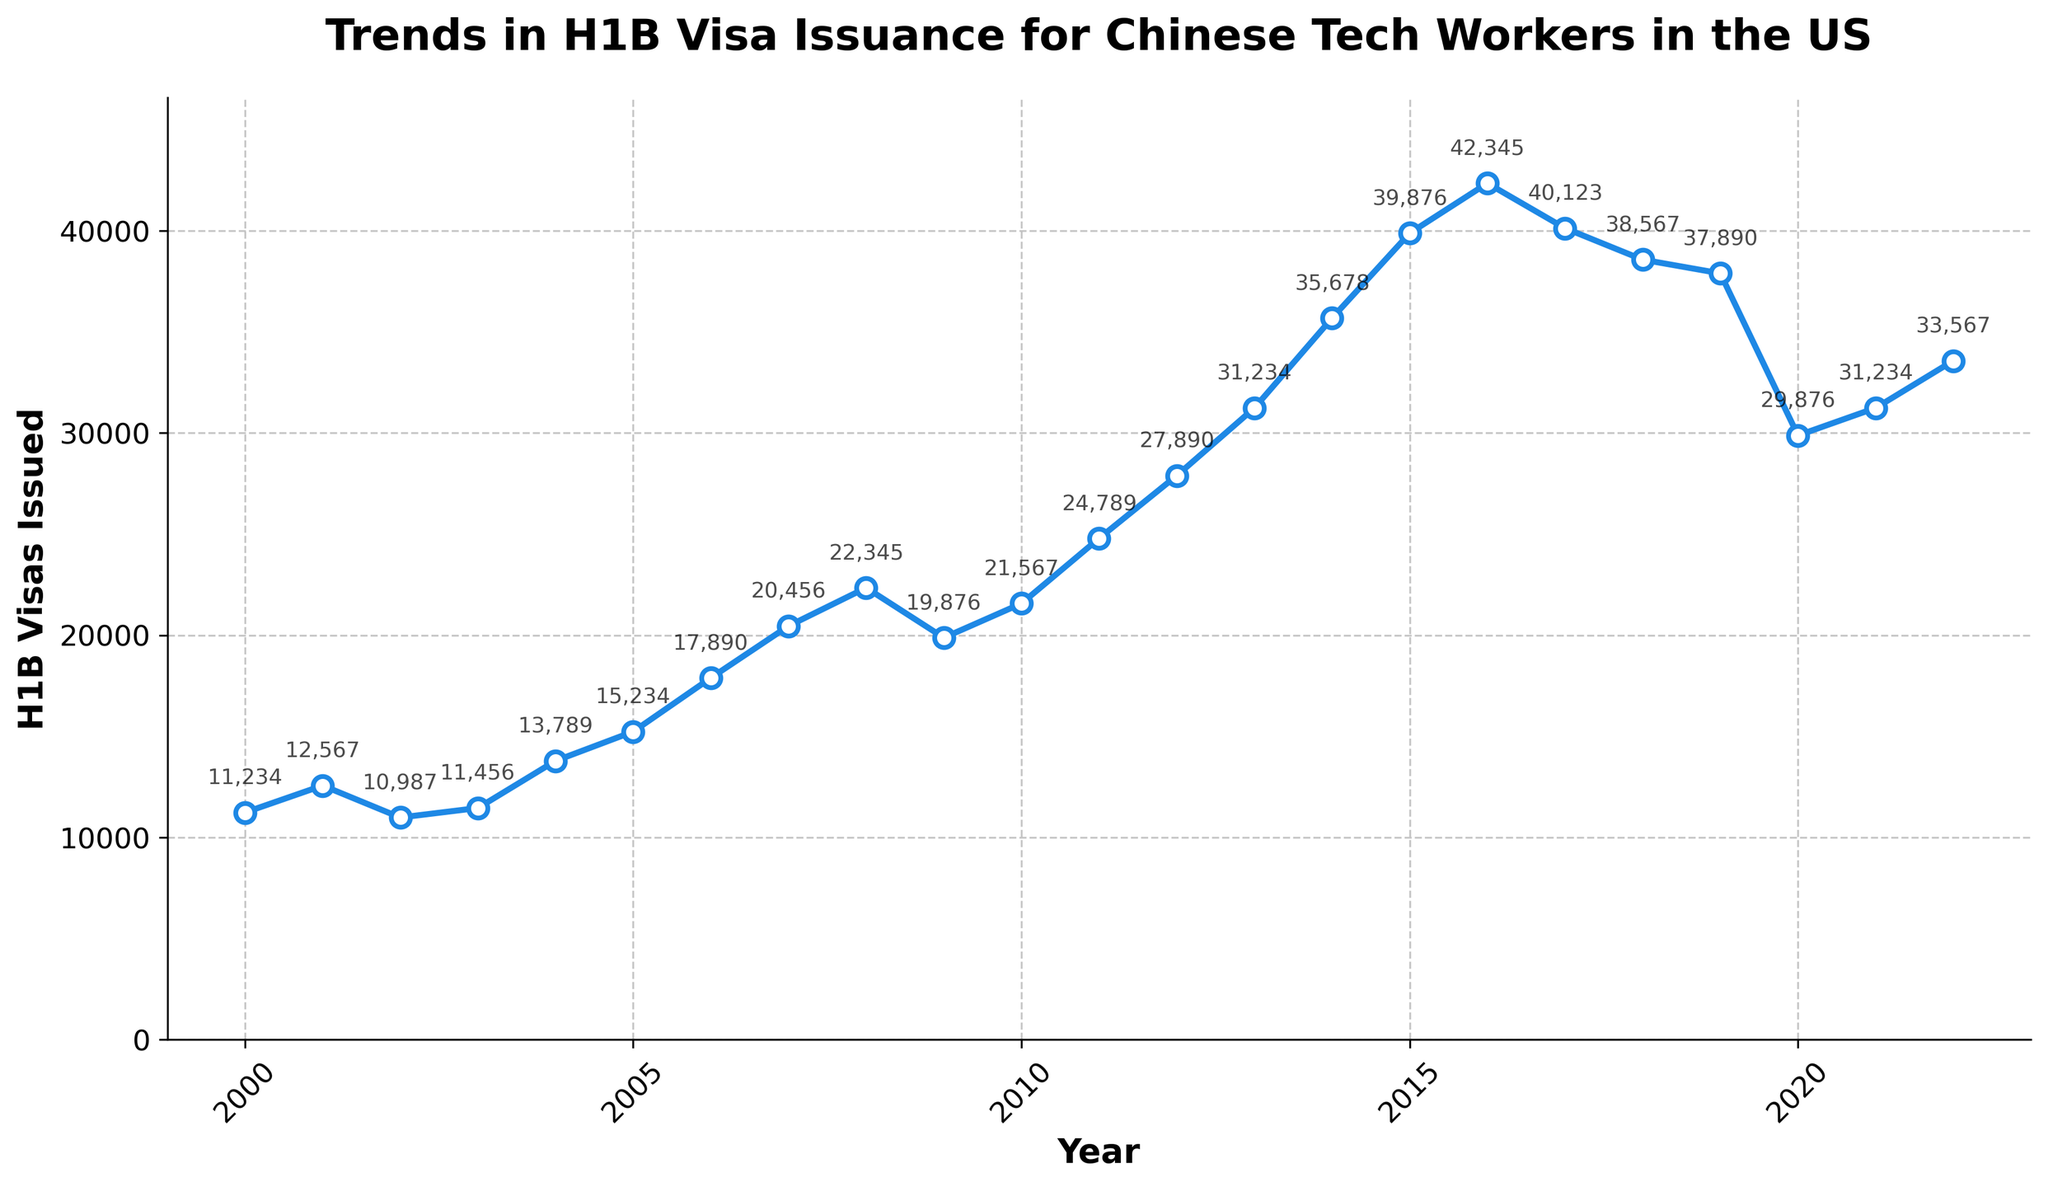What is the peak year for H1B visa issuance to Chinese tech workers? The peak year can be identified by finding the year with the highest number of H1B visas issued. The chart shows that the highest value is in 2016 with 42,345 visas issued.
Answer: 2016 Between 2000 and 2022, which year experienced the largest drop in H1B visa issuance compared to the previous year? To determine the largest drop, we need to find the year-to-year differences and identify the largest negative difference. The biggest drop is between 2019 and 2020 (37,890 to 29,876), a decrease of 8,014.
Answer: 2020 What is the overall trend in H1B visa issuance from 2000 to 2022? Observing the data points, the overall trend shows an increase in visa issuance from 2000 to 2016, followed by fluctuations and a notable decrease in 2020, before stabilizing again.
Answer: Increasing until 2016, then fluctuating with a decrease in 2020, and stabilizing From 2011 to 2015, how much did the number of H1B visas issued increase? To find the increase, subtract the number of visas issued in 2011 from those issued in 2015: 39,876 (2015) - 24,789 (2011) = 15,087.
Answer: 15,087 How does the number of H1B visas issued in 2020 compare to those in 2010? Comparing the values for 2020 (29,876) and 2010 (21,567), we see that 2020 had more visas issued by 29,876 - 21,567 = 8,309.
Answer: 8,309 more in 2020 How did the number of H1B visas issued change from 2019 to 2021? The number of visas issued in 2019 was 37,890, in 2020 it was 29,876, and in 2021 it was 31,234. So, from 2019 to 2020 there was a decrease of 8,014, and from 2020 to 2021 there was an increase of 1,358. Overall, it's a decrease of 37,890 - 31,234 = 6,656.
Answer: Decreased by 6,656 Between 2017 and 2018, what was the percentage decrease in H1B visas issued? The number of visas issued in 2017 was 40,123, and in 2018 it was 38,567. The percentage decrease is calculated as ((40,123 - 38,567) / 40,123) * 100 ≈ 3.89%.
Answer: 3.89% Which year had a higher number of H1B visas issued, 2003 or 2022? By comparing the data values for the two years: 11,456 in 2003 and 33,567 in 2022, it can be seen that 2022 had a higher number of visas.
Answer: 2022 What is the average number of H1B visas issued annually from 2000 to 2010? Sum the values from 2000 to 2010 and divide by the number of years (11). The total is 199,643, so the average is 199,643 / 11 ≈ 18,150.
Answer: 18,150 